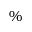Convert formula to latex. <formula><loc_0><loc_0><loc_500><loc_500>\%</formula> 